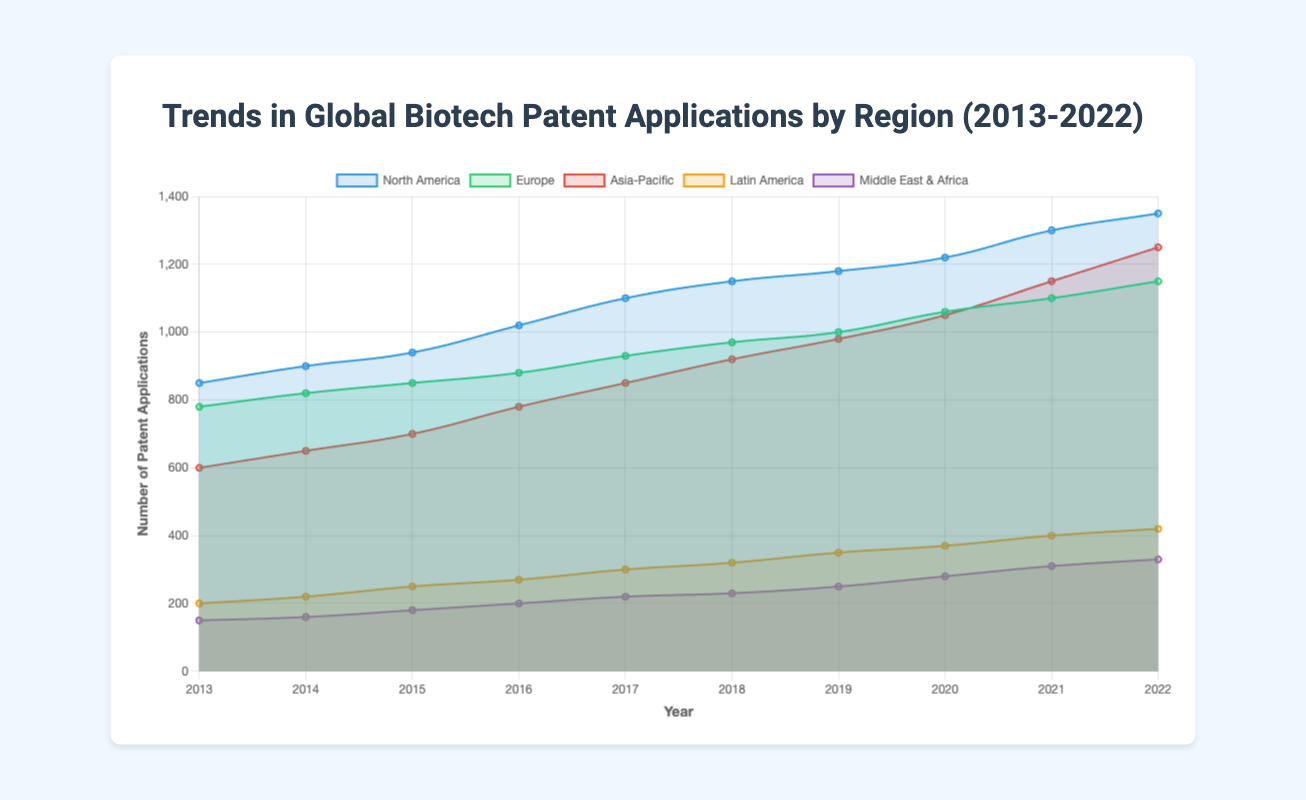What's the relative increase in biotech patent applications in North America from 2013 to 2022? To find the relative increase, first calculate the increase in patent applications: 1350 (2022) - 850 (2013) = 500. Then, divide the increase by the starting value (2013): 500/850. Finally, multiply by 100 to convert to a percentage: (500/850) * 100 ≈ 58.82%
Answer: 58.82% Compare the trend in biotech patent applications between Europe and Asia-Pacific from 2015 to 2022. Which region had a larger increase? For Europe: 1150 (2022) - 850 (2015) = 300. For Asia-Pacific: 1250 (2022) - 700 (2015) = 550. Comparing the two increases, Asia-Pacific had a larger increase (550 vs 300).
Answer: Asia-Pacific Which region had the smallest growth in biotech patent applications over the entire decade? To determine this, examine the initial (2013) and final (2022) values for each region: North America (500), Europe (370), Asia-Pacific (650), Latin America (220), Middle East & Africa (180). The smallest growth is in the Middle East & Africa with an increase of 180.
Answer: Middle East & Africa What was the average number of biotech patent applications in Latin America over the decade? Sum all the yearly values: 200 + 220 + 250 + 270 + 300 + 320 + 350 + 370 + 400 + 420 = 3100. Divide by the number of years (10): 3100 / 10 = 310.
Answer: 310 In which year did Europe surpass 1000 biotech patent applications? By looking at the data points for Europe, Europe surpasses 1000 in 2019 where the value is 1060.
Answer: 2019 Which region had the highest number of biotech patent applications in 2017? By comparing the numbers for each region in 2017, the highest is North America with 1100.
Answer: North America By how much did the number of biotech patent applications increase for the Middle East & Africa from 2013 to 2016? Subtract the number in 2013 from the number in 2016: 200 - 150 = 50. This is the increase in biotech patent applications.
Answer: 50 Compare the growth rates (as percentages) from 2016 to 2017 for Europe and Latin America. Which region experienced higher growth? Calculate the growth for Europe: (930 - 880) / 880 * 100 ≈ 5.68%. Calculate the growth for Latin America: (300 - 270) / 270 * 100 ≈ 11.11%. Latin America experienced the higher growth rate.
Answer: Latin America Which color represents the trend line for the region with the second-highest number of biotech patent applications in 2022? Based on the order of the regions and the colors assigned, Europe is the region with the second-highest number (1150) and its trend line is green.
Answer: green 